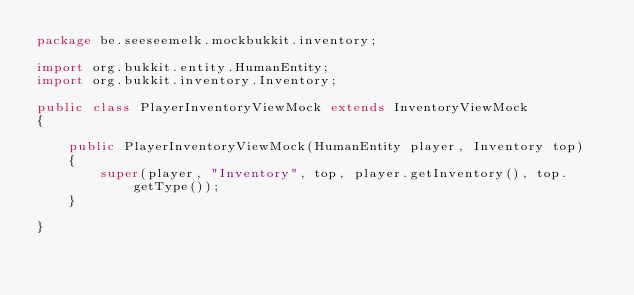Convert code to text. <code><loc_0><loc_0><loc_500><loc_500><_Java_>package be.seeseemelk.mockbukkit.inventory;

import org.bukkit.entity.HumanEntity;
import org.bukkit.inventory.Inventory;

public class PlayerInventoryViewMock extends InventoryViewMock
{

	public PlayerInventoryViewMock(HumanEntity player, Inventory top)
	{
		super(player, "Inventory", top, player.getInventory(), top.getType());
	}

}
</code> 